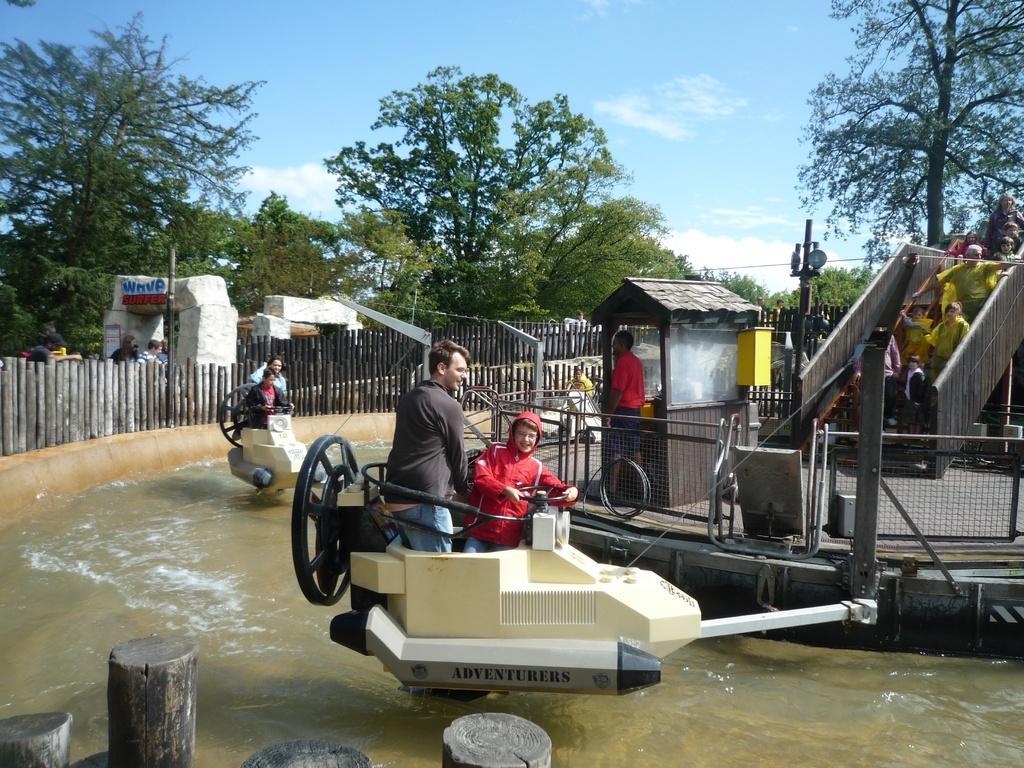In one or two sentences, can you explain what this image depicts? This image is representing wave park,which we can see on the left side. In the image in the center we can see water rides,fences,control room,staircase,pole and few people were standing. On the water ride,we can see few people were sitting. On the bottom left of the image we can see woods. In the background we can see the sky,clouds,trees,fence,arch and few people were standing. 